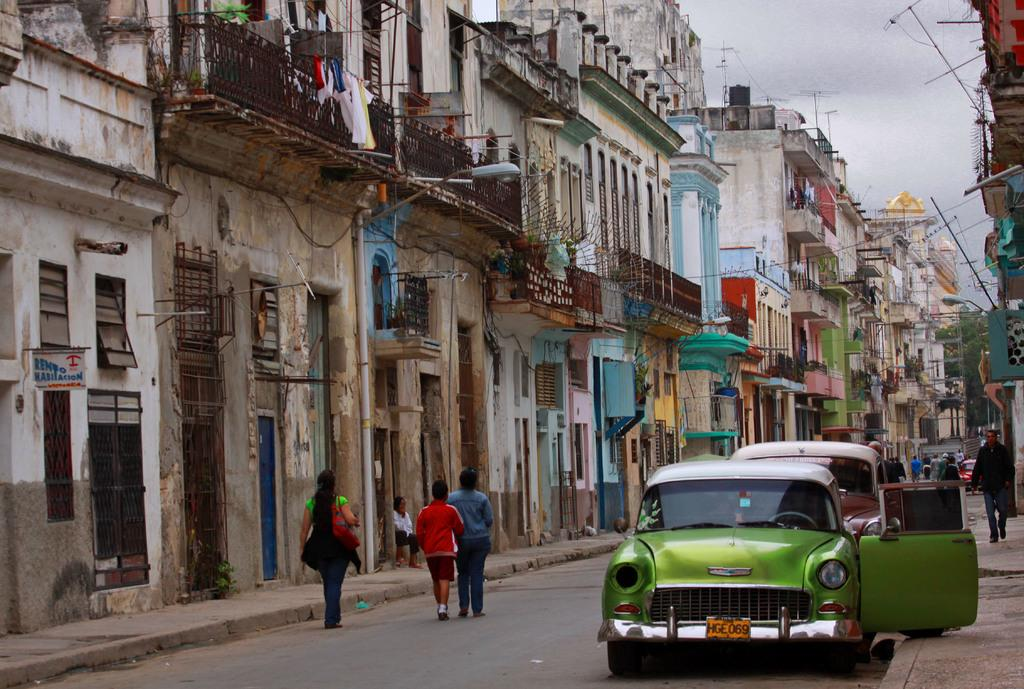What is on the road in the image? There is a vehicle on the road in the image. Are there any people present in the image? Yes, there are people on the road and a person walking on a footpath. What can be seen in the buildings in the image? There are buildings with windows in the image. Where is the pocket located in the image? There is no pocket present in the image. What type of attraction can be seen in the image? There is no attraction present in the image. 